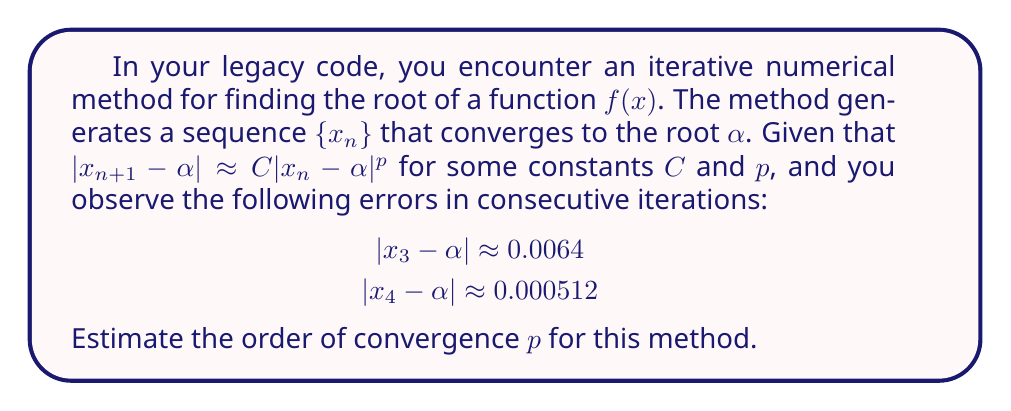Can you answer this question? To estimate the order of convergence $p$, we can use the given information and the definition of the convergence rate:

1) We know that $|x_{n+1} - \alpha| \approx C|x_n - \alpha|^p$

2) Taking the logarithm of both sides:
   $$\log|x_{n+1} - \alpha| \approx \log C + p \log|x_n - \alpha|$$

3) For consecutive iterations:
   $$\log|x_4 - \alpha| \approx \log C + p \log|x_3 - \alpha|$$

4) Substituting the given values:
   $$\log(0.000512) \approx \log C + p \log(0.0064)$$

5) Simplifying:
   $$-7.5778 \approx \log C + p(-5.0515)$$

6) We don't know $C$, but we can eliminate it by using the ratio of consecutive errors:
   $$\frac{|x_4 - \alpha|}{|x_3 - \alpha|} \approx \left(\frac{|x_3 - \alpha|}{|x_2 - \alpha|}\right)^p$$

7) Substituting the given values:
   $$\frac{0.000512}{0.0064} \approx (0.0064)^{p-1}$$

8) Simplifying:
   $$0.08 \approx 0.0064^{p-1}$$

9) Taking logarithms of both sides:
   $$\log(0.08) \approx (p-1)\log(0.0064)$$

10) Solving for $p$:
    $$p \approx 1 + \frac{\log(0.08)}{\log(0.0064)} \approx 1 + \frac{-2.5257}{-5.0515} \approx 2$$

Therefore, the estimated order of convergence is approximately 2.
Answer: $p \approx 2$ 